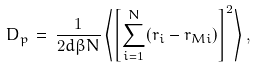<formula> <loc_0><loc_0><loc_500><loc_500>D _ { p } \, = \, \frac { 1 } { 2 d \beta N } \left \langle \left [ \sum _ { i = 1 } ^ { N } ( r _ { i } - r _ { M i } ) \right ] ^ { 2 } \right \rangle ,</formula> 